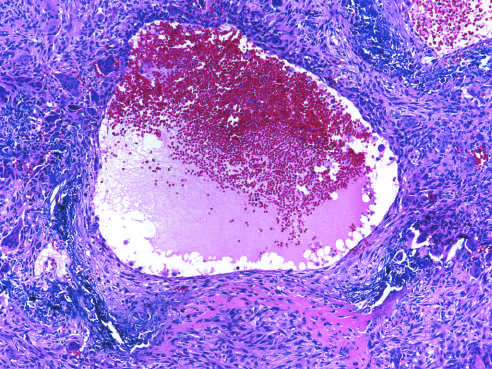what is surrounded by a fibrous wall containing proliferating fibroblasts, reactive woven bone, and osteoclast-type giant cells?
Answer the question using a single word or phrase. Aneurysmal bone cyst with blood-filled cystic space 